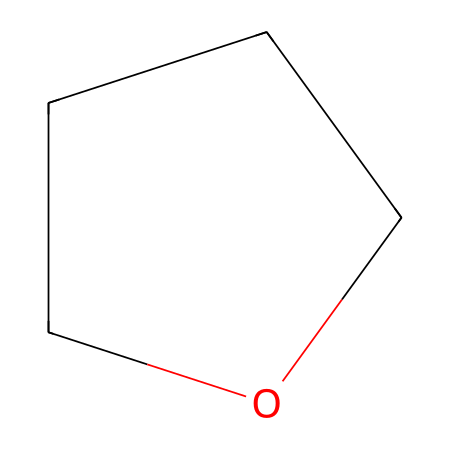What is the molecular formula of this compound? By examining the SMILES representation "C1CCCO1", we can identify the number of carbon (C) and oxygen (O) atoms. There are four carbons (C) and one oxygen (O), resulting in a molecular formula of C4H8O (considering the hydrogen atoms that balance the valency).
Answer: C4H8O How many carbon atoms are in the structure? The SMILES notation "C1CCCO1" indicates that there are four distinct carbon atoms represented. We count the 'C's in the structure to find that there are four.
Answer: 4 What type of chemical compound is indicated by the structure? The presence of a cyclic ether structure with the SMILES representation indicates that it is classified as an ether due to the C-O bond formation within a ring. The presence of oxygen as part of a cyclic structure also solidifies this classification.
Answer: ether What is the total number of hydrogen atoms in the compound? In the molecular formula C4H8O derived from the structure "C1CCCO1", there are eight hydrogen atoms that accompany the four carbons and one oxygen. This can be validated by the tetravalent nature of carbon and its bonding to hydrogen atoms.
Answer: 8 What type of reaction is tetrahydrofuran commonly involved in? Tetrahydrofuran is known to act as a solvent and a reactant in various polymerization reactions, specifically in the production of certain plastics and adhesives, signifying its utility as a solvent.
Answer: polymerization What is the significance of the ring structure in tetrahydrofuran? The ring structure in tetrahydrofuran enhances its stability and lends it unique properties, such as low boiling point and good solvent characteristics, which are beneficial in applications like adhesives and plastics.
Answer: stability 